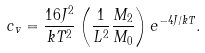<formula> <loc_0><loc_0><loc_500><loc_500>c _ { v } = \frac { 1 6 J ^ { 2 } } { k T ^ { 2 } } \left ( \frac { 1 } { L ^ { 2 } } \frac { M _ { 2 } } { M _ { 0 } } \right ) e ^ { - 4 J / k T } .</formula> 